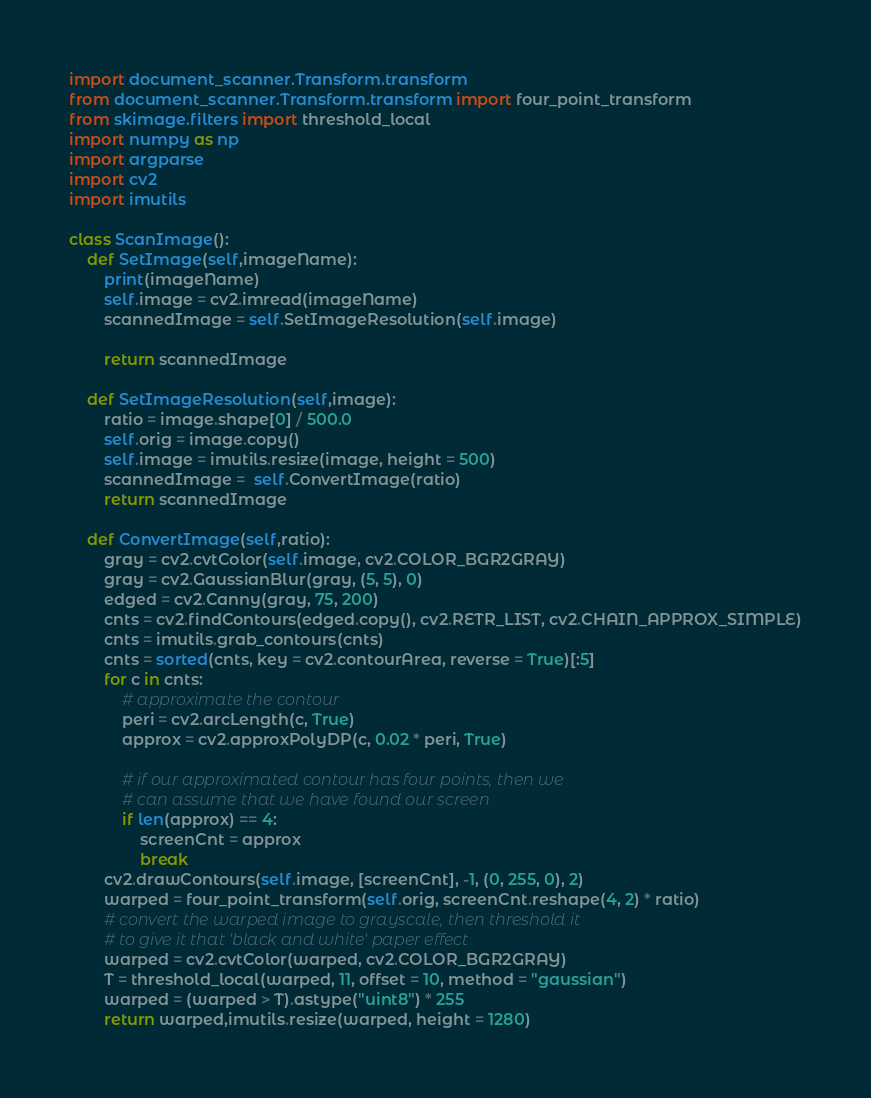<code> <loc_0><loc_0><loc_500><loc_500><_Python_>import document_scanner.Transform.transform
from document_scanner.Transform.transform import four_point_transform
from skimage.filters import threshold_local
import numpy as np
import argparse
import cv2
import imutils

class ScanImage():
	def SetImage(self,imageName):
		print(imageName)
		self.image = cv2.imread(imageName)
		scannedImage = self.SetImageResolution(self.image)

		return scannedImage

	def SetImageResolution(self,image):
		ratio = image.shape[0] / 500.0
		self.orig = image.copy()
		self.image = imutils.resize(image, height = 500)
		scannedImage =  self.ConvertImage(ratio)
		return scannedImage
		
	def ConvertImage(self,ratio):
		gray = cv2.cvtColor(self.image, cv2.COLOR_BGR2GRAY)
		gray = cv2.GaussianBlur(gray, (5, 5), 0)
		edged = cv2.Canny(gray, 75, 200)
		cnts = cv2.findContours(edged.copy(), cv2.RETR_LIST, cv2.CHAIN_APPROX_SIMPLE)
		cnts = imutils.grab_contours(cnts)
		cnts = sorted(cnts, key = cv2.contourArea, reverse = True)[:5]
		for c in cnts:
    		# approximate the contour
			peri = cv2.arcLength(c, True)
			approx = cv2.approxPolyDP(c, 0.02 * peri, True)

			# if our approximated contour has four points, then we
			# can assume that we have found our screen
			if len(approx) == 4:
				screenCnt = approx
				break
		cv2.drawContours(self.image, [screenCnt], -1, (0, 255, 0), 2)
		warped = four_point_transform(self.orig, screenCnt.reshape(4, 2) * ratio)
		# convert the warped image to grayscale, then threshold it
		# to give it that 'black and white' paper effect
		warped = cv2.cvtColor(warped, cv2.COLOR_BGR2GRAY)
		T = threshold_local(warped, 11, offset = 10, method = "gaussian")
		warped = (warped > T).astype("uint8") * 255
		return warped,imutils.resize(warped, height = 1280)
</code> 